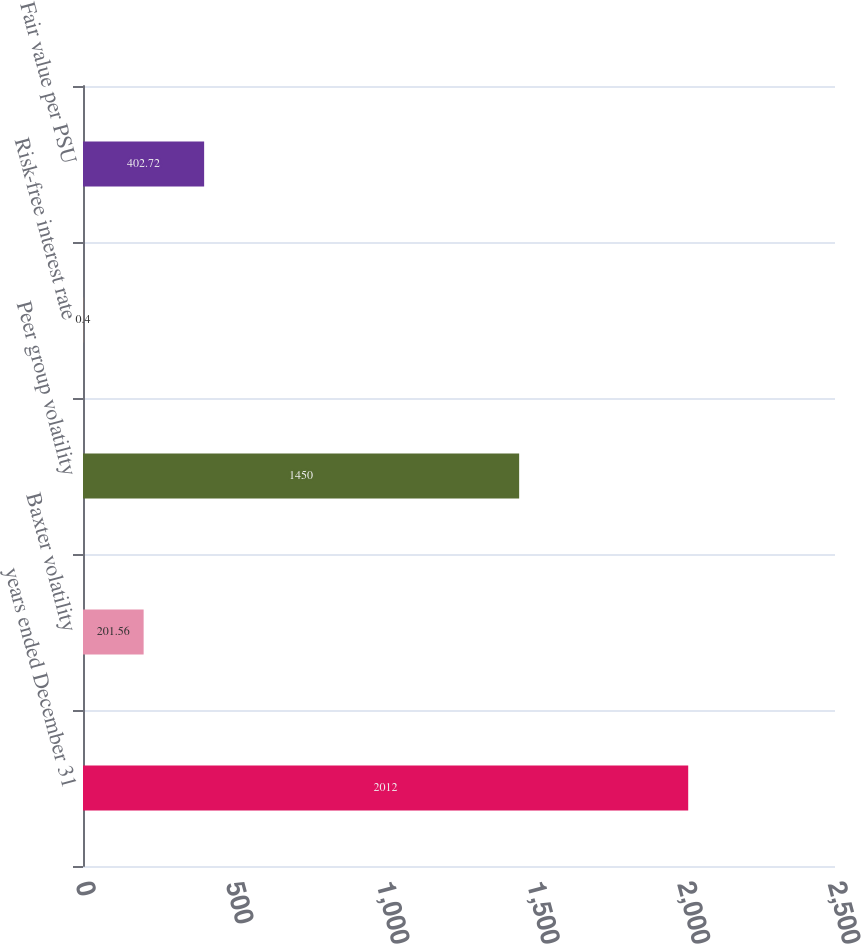<chart> <loc_0><loc_0><loc_500><loc_500><bar_chart><fcel>years ended December 31<fcel>Baxter volatility<fcel>Peer group volatility<fcel>Risk-free interest rate<fcel>Fair value per PSU<nl><fcel>2012<fcel>201.56<fcel>1450<fcel>0.4<fcel>402.72<nl></chart> 